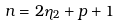Convert formula to latex. <formula><loc_0><loc_0><loc_500><loc_500>n = 2 \eta _ { 2 } + p + 1</formula> 